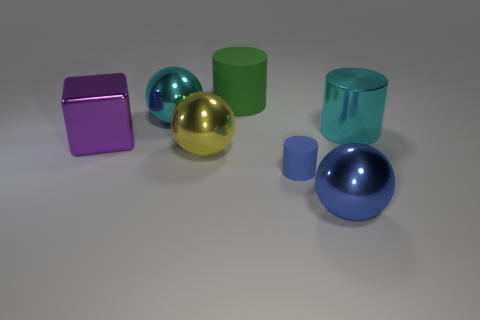Add 3 large green rubber things. How many objects exist? 10 Subtract all big yellow spheres. How many spheres are left? 2 Subtract 2 cylinders. How many cylinders are left? 1 Subtract all blue balls. How many balls are left? 2 Subtract all red balls. How many green cylinders are left? 1 Subtract all tiny purple spheres. Subtract all large blue shiny things. How many objects are left? 6 Add 2 matte objects. How many matte objects are left? 4 Add 5 big cyan metal things. How many big cyan metal things exist? 7 Subtract 1 purple blocks. How many objects are left? 6 Subtract all blocks. How many objects are left? 6 